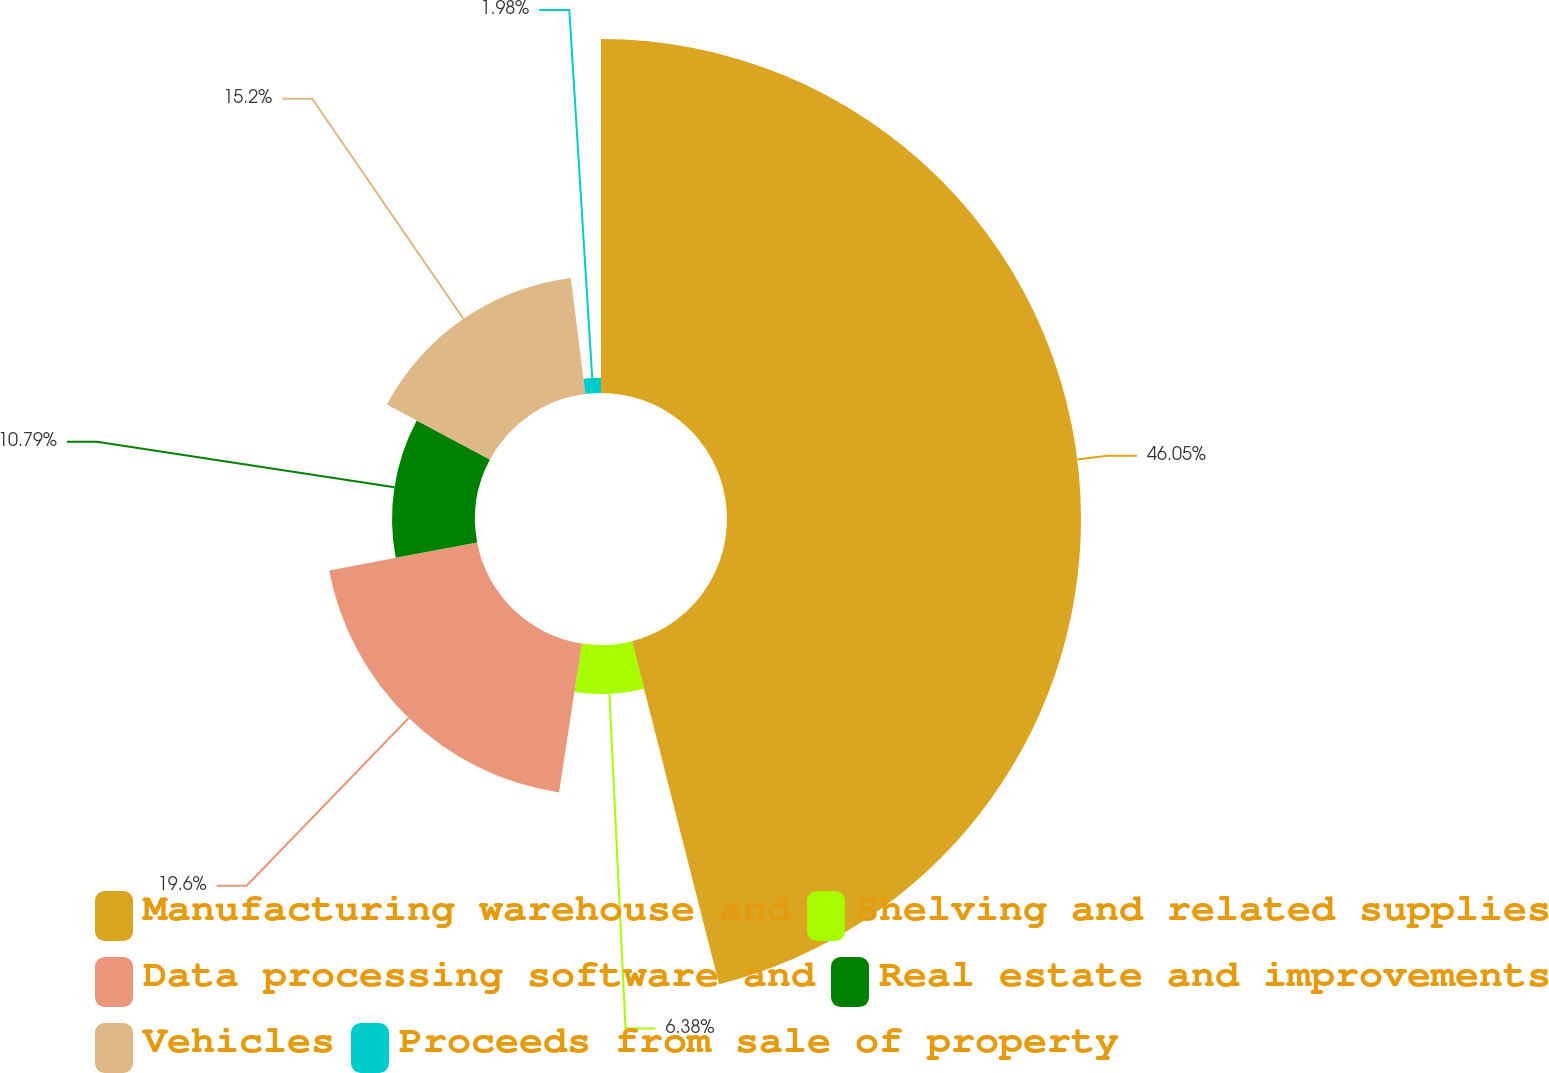Convert chart. <chart><loc_0><loc_0><loc_500><loc_500><pie_chart><fcel>Manufacturing warehouse and<fcel>Shelving and related supplies<fcel>Data processing software and<fcel>Real estate and improvements<fcel>Vehicles<fcel>Proceeds from sale of property<nl><fcel>46.04%<fcel>6.38%<fcel>19.6%<fcel>10.79%<fcel>15.2%<fcel>1.98%<nl></chart> 